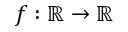Convert formula to latex. <formula><loc_0><loc_0><loc_500><loc_500>f \colon \mathbb { R } \to \mathbb { R }</formula> 